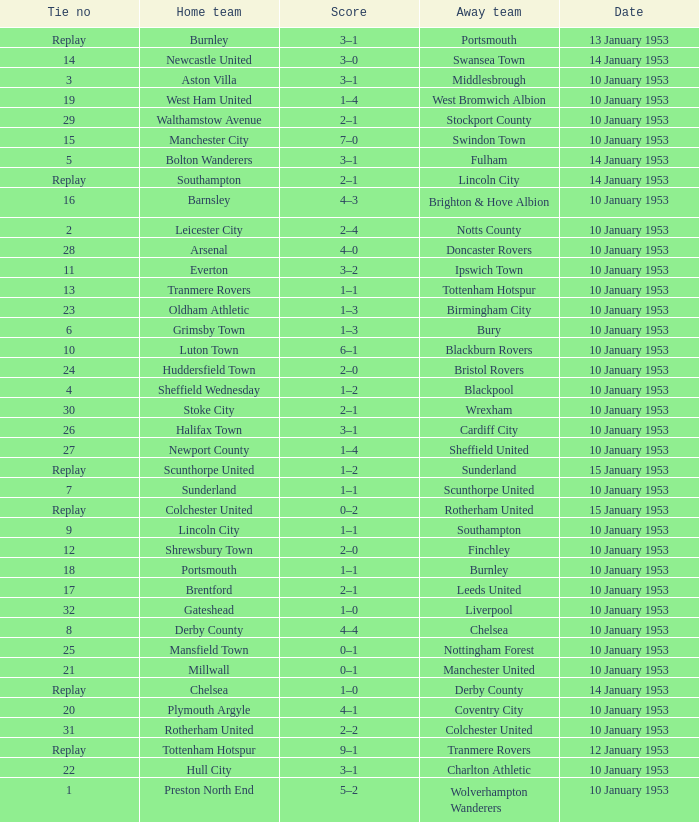What home team has coventry city as the away team? Plymouth Argyle. 